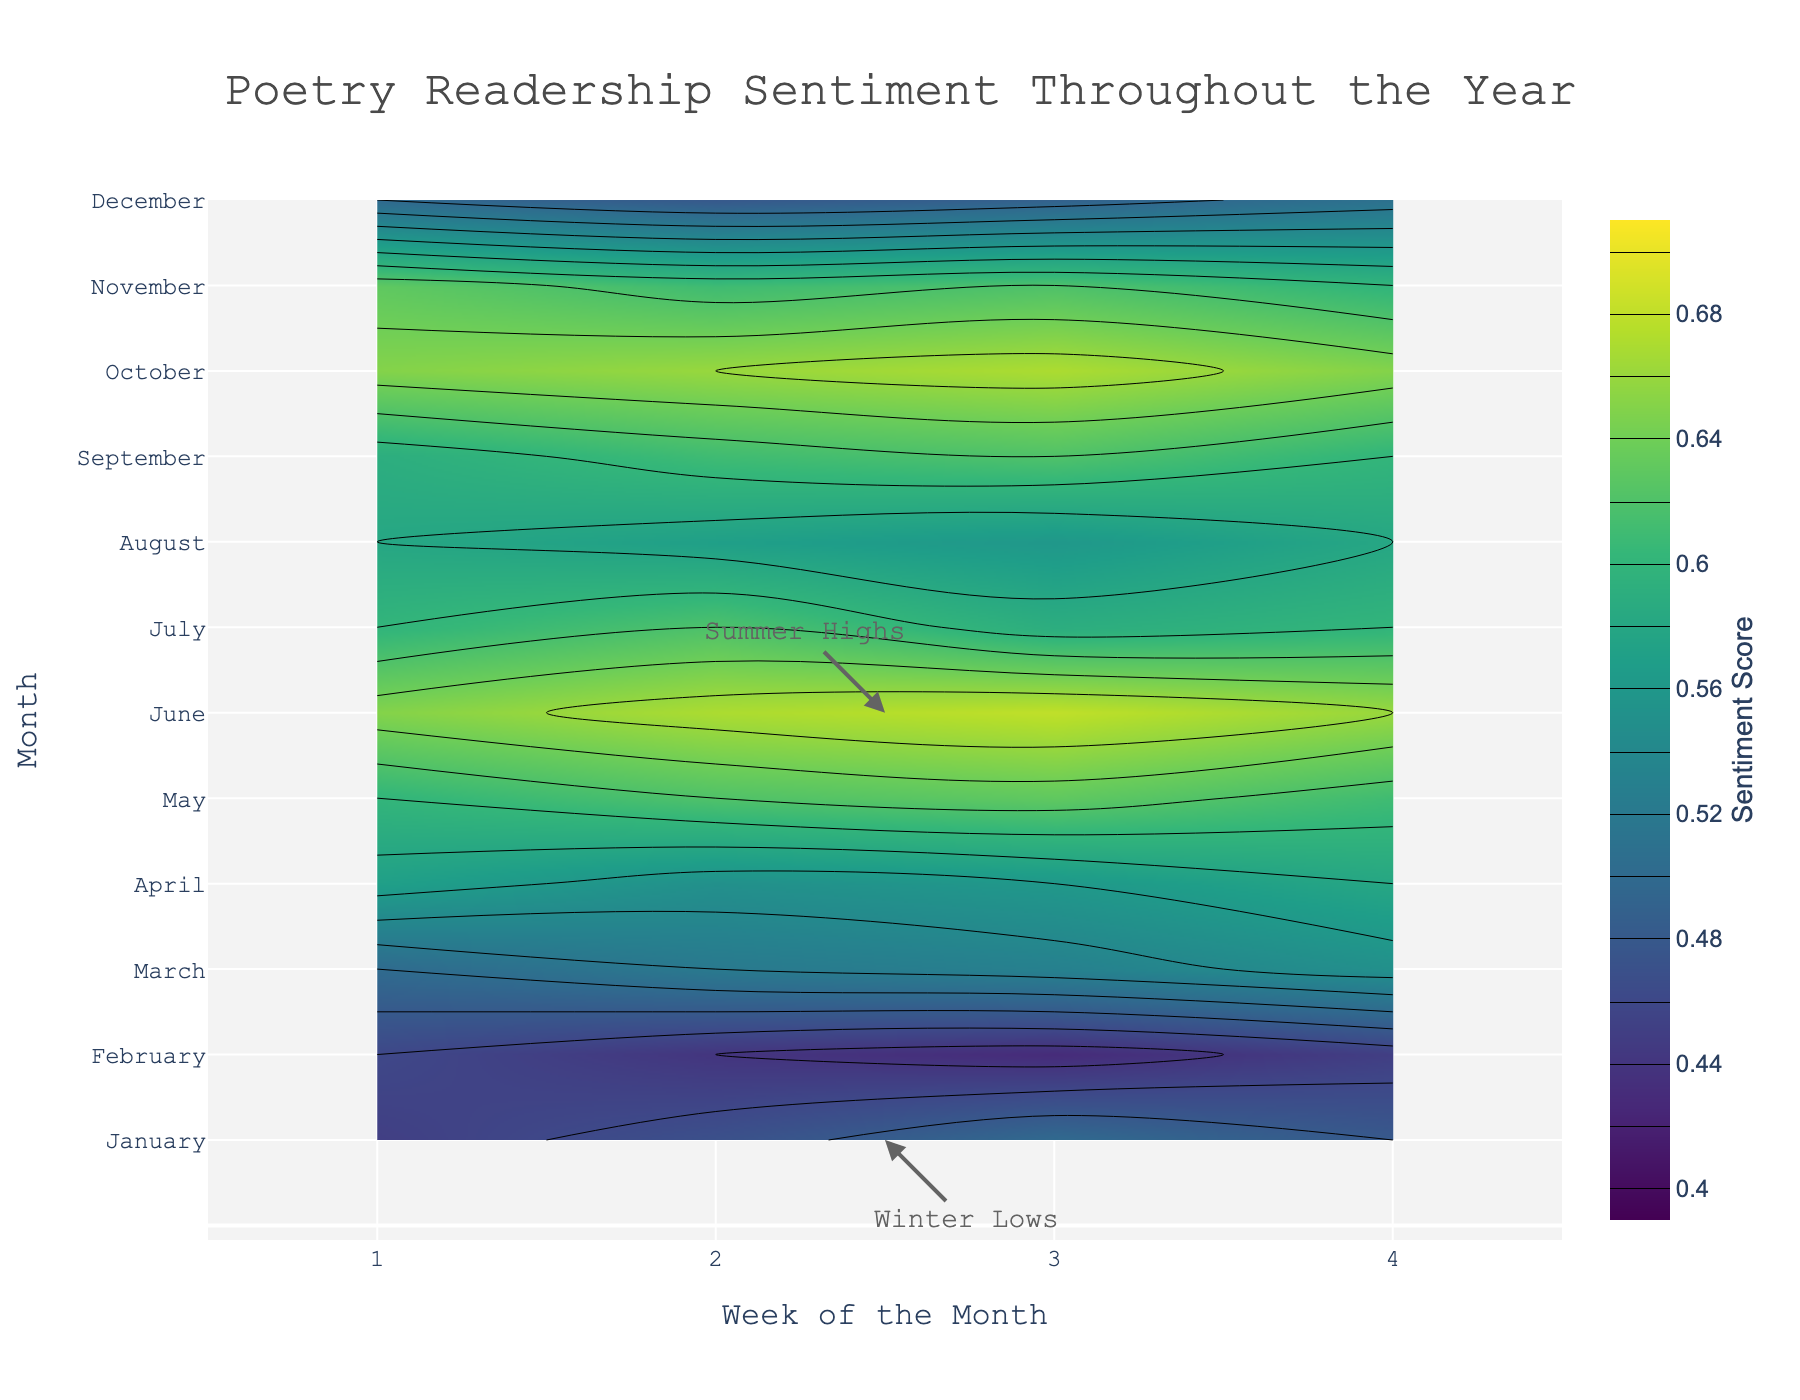What is the title of the figure? The title is prominently displayed at the top center of the figure. It reads: "Poetry Readership Sentiment Throughout the Year."
Answer: Poetry Readership Sentiment Throughout the Year What does the colorbar indicate? The colorbar on the right side of the figure, labeled "Sentiment Score," indicates the range of sentiment scores in the data. The colors range from dark purple to yellow-green.
Answer: Sentiment Score Which month shows the highest sentiment score? By examining the color gradient, the highest sentiment scores are shown in June with shades of yellow-green. The highest sentiment (0.68) is in the third week of June.
Answer: June How does the sentiment score in January compare to April? January's sentiment scores range from 0.45 to 0.50, while April's range from 0.55 to 0.58. This indicates April has higher sentiment scores compared to January.
Answer: April has higher sentiment scores What pattern is observable in the sentiment scores during summer? From June to August, sentiment scores are relatively high. June shows the highest scores (up to 0.68), followed by slightly lower scores in July and August. A discernible dip occurs in July through to August.
Answer: High in June, dips in July and August What are the general trends in sentiment scores from March to May? The sentiment scores progressively increase from March (0.50 to 0.55) to May (0.60 to 0.63). This period showcases a notable rise in sentiment scores.
Answer: Increasing trend Which month shows the lowest sentiment score, and what is it? The lowest sentiment scores are indicated by the darkest shades of purple. December shows the lowest sentiment score of approximately 0.48 (second week).
Answer: December What can be inferred from the annotations labeled "Summer Highs" and "Winter Lows"? The annotations emphasize two notable patterns: "Summer Highs" refers to the peak sentiment scores during June, while "Winter Lows" points out the lower sentiment scores in January.
Answer: Peaks in June and lows in January How do the first and last weeks of October compare in terms of sentiment score? October's first and last weeks have very close sentiment scores, both around 0.65, indicating a consistent sentiment throughout the month.
Answer: Both around 0.65 What's the average sentiment score for the month of July? July's sentiment scores are: 0.60, 0.62, 0.59, and 0.60. Sum these (0.60 + 0.62 + 0.59 + 0.60) = 2.41, and divide by 4 weeks gives the average: 2.41 / 4 = 0.6025.
Answer: 0.6025 